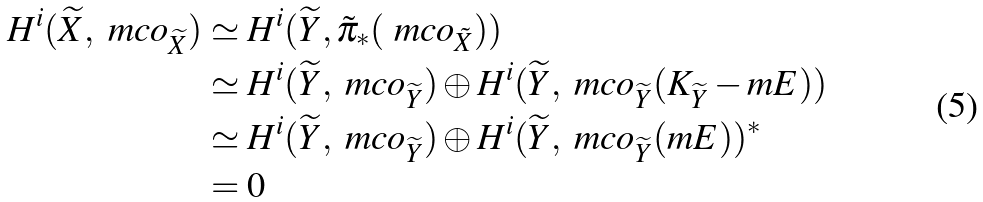<formula> <loc_0><loc_0><loc_500><loc_500>H ^ { i } ( \widetilde { X } , \ m c o _ { \widetilde { X } } ) & \simeq H ^ { i } ( \widetilde { Y } , \tilde { \pi } _ { * } ( \ m c o _ { \tilde { X } } ) ) \\ & \simeq H ^ { i } ( \widetilde { Y } , \ m c o _ { \widetilde { Y } } ) \oplus H ^ { i } ( \widetilde { Y } , \ m c o _ { \widetilde { Y } } ( K _ { \widetilde { Y } } - m E ) ) \\ & \simeq H ^ { i } ( \widetilde { Y } , \ m c o _ { \widetilde { Y } } ) \oplus H ^ { i } ( \widetilde { Y } , \ m c o _ { \widetilde { Y } } ( m E ) ) ^ { * } \\ & = 0</formula> 